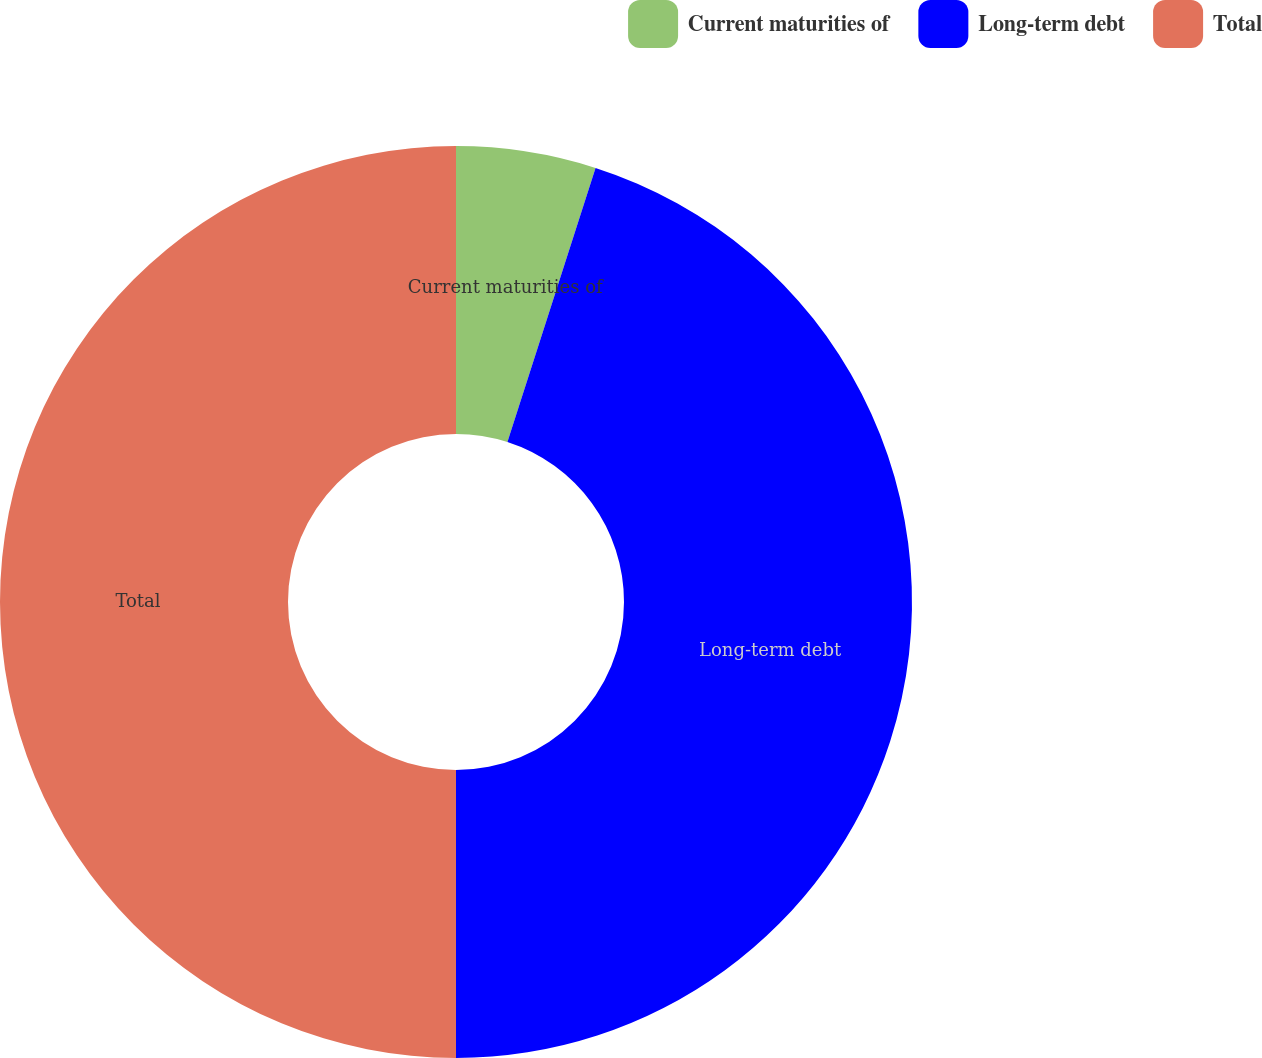Convert chart to OTSL. <chart><loc_0><loc_0><loc_500><loc_500><pie_chart><fcel>Current maturities of<fcel>Long-term debt<fcel>Total<nl><fcel>4.95%<fcel>45.05%<fcel>50.0%<nl></chart> 